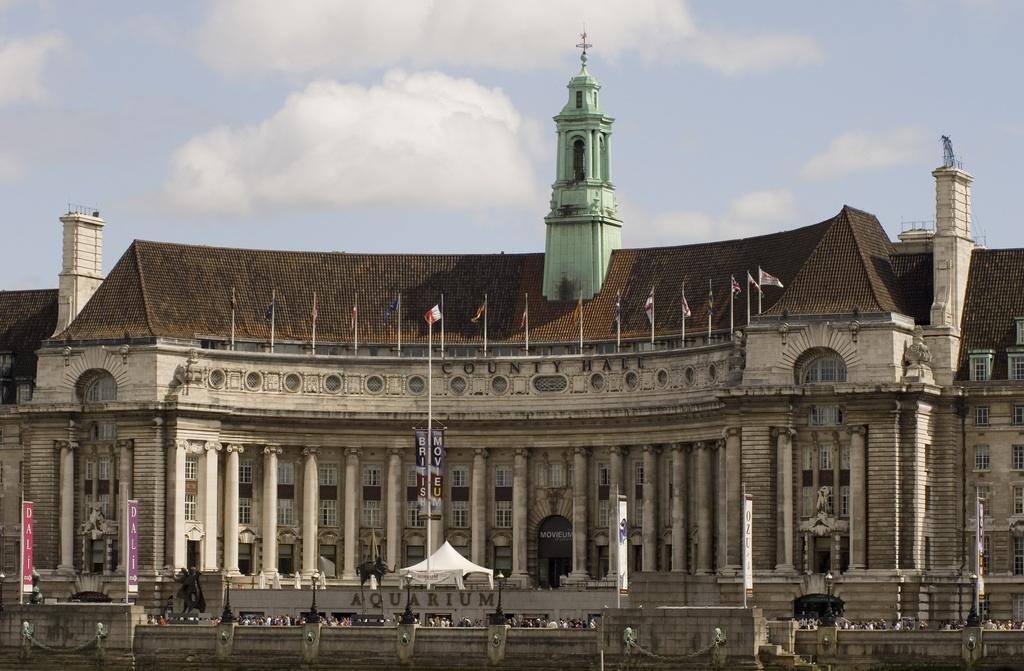Describe this image in one or two sentences. In this image I can see building, in front of the building I can see a tent and hoarding board and poles ,at the top I can see the sky. 